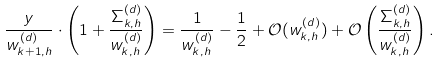<formula> <loc_0><loc_0><loc_500><loc_500>\frac { y } { w _ { k + 1 , h } ^ { ( d ) } } \cdot \left ( 1 + \frac { \Sigma _ { k , h } ^ { ( d ) } } { w _ { k , h } ^ { ( d ) } } \right ) = \frac { 1 } { w _ { k , h } ^ { ( d ) } } - \frac { 1 } { 2 } + \mathcal { O } ( w _ { k , h } ^ { ( d ) } ) + \mathcal { O } \left ( \frac { \Sigma _ { k , h } ^ { ( d ) } } { w _ { k , h } ^ { ( d ) } } \right ) .</formula> 